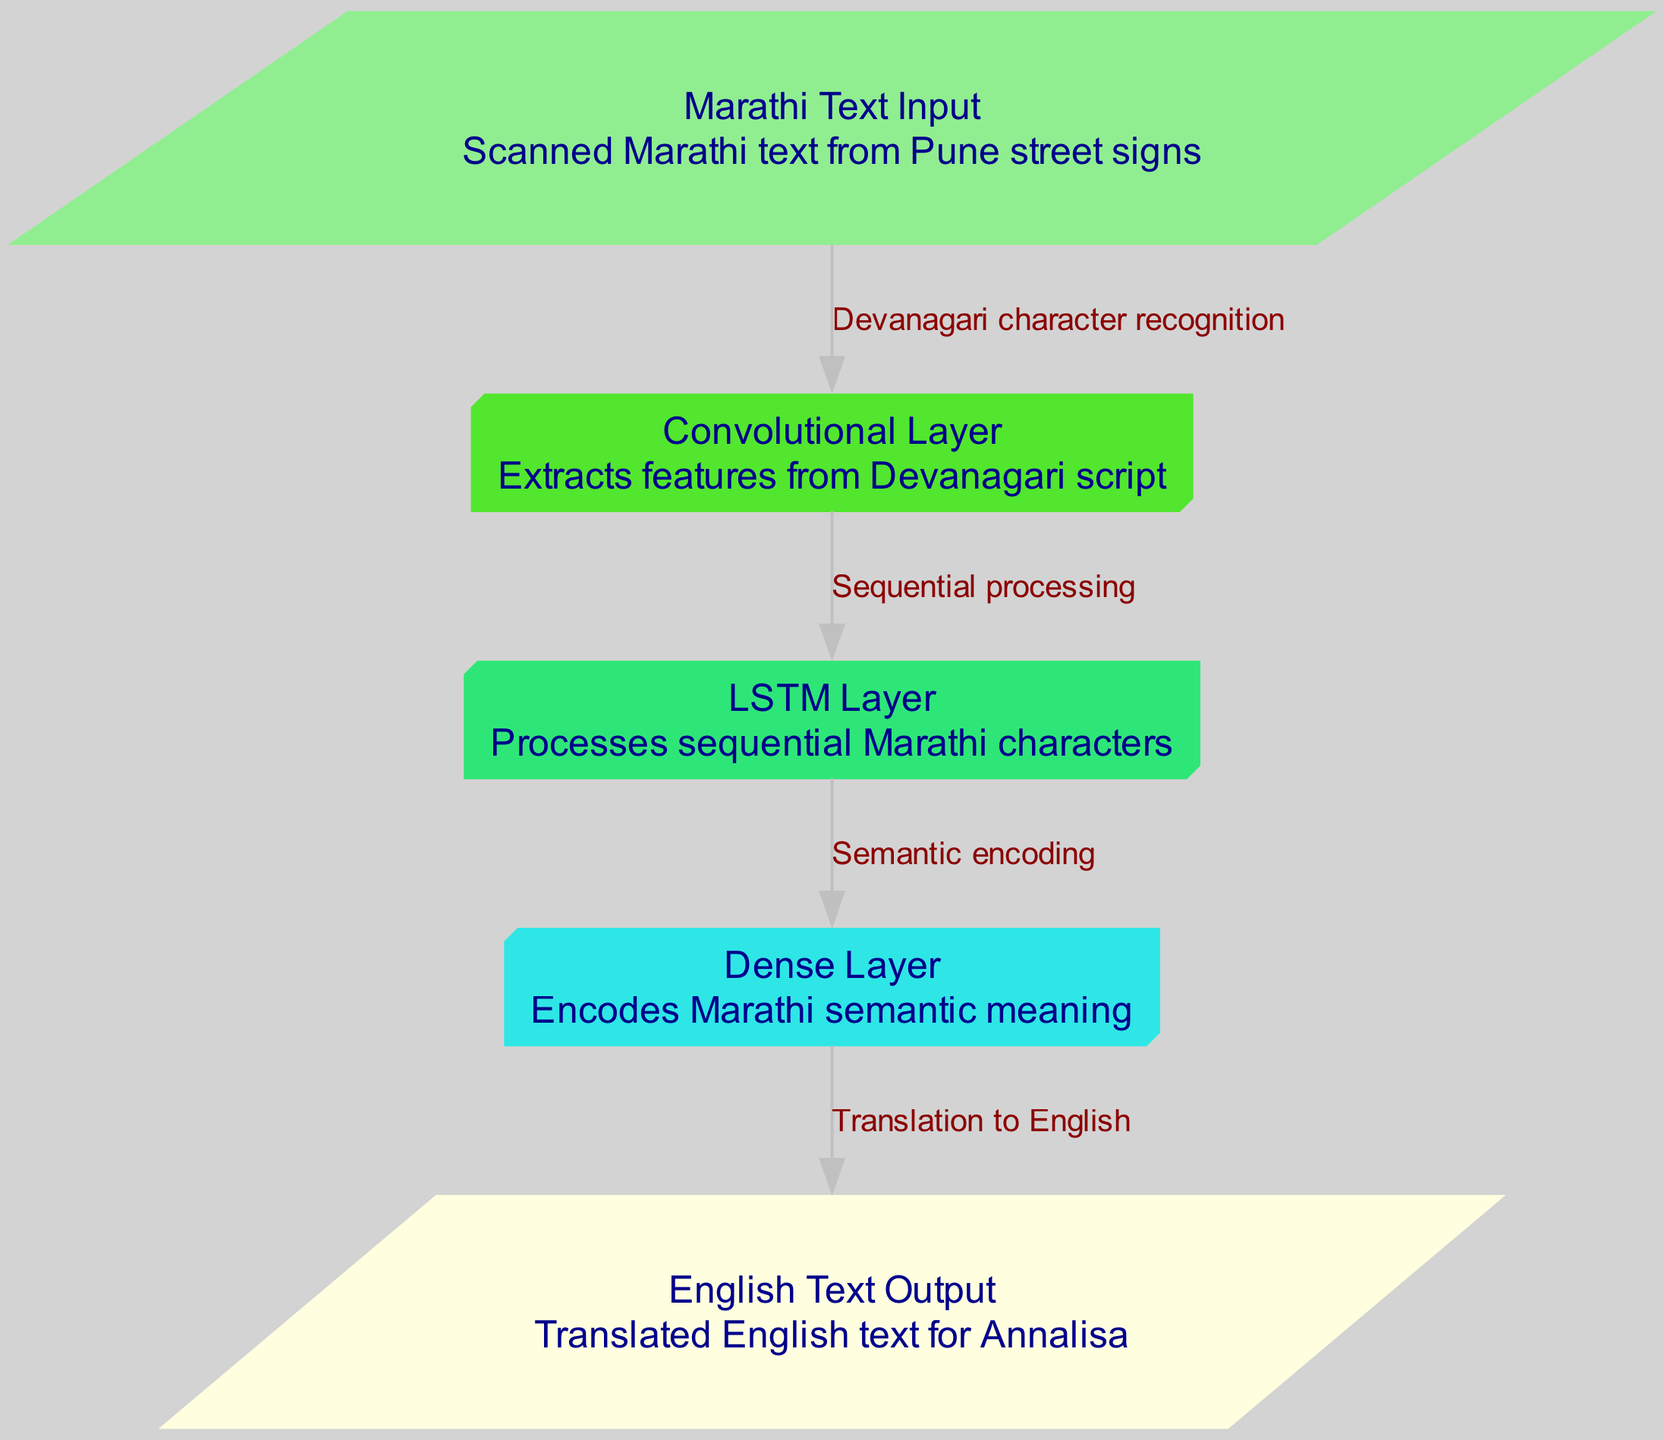What is the input layer of the diagram? The input layer is labeled "Marathi Text Input," and its description mentions "Scanned Marathi text from Pune street signs."
Answer: Marathi Text Input How many hidden layers are present in the neural network? The diagram indicates there are three hidden layers: a Convolutional Layer, an LSTM Layer, and a Dense Layer.
Answer: 3 What does the Convolutional Layer do? The Convolutional Layer is described as "Extracts features from Devanagari script," indicating its role in identifying patterns in the input text.
Answer: Extracts features from Devanagari script Which layer processes the sequential Marathi characters? The diagram specifies that the LSTM Layer processes sequential Marathi characters, as described in its function.
Answer: LSTM Layer What is the purpose of the Dense Layer in the diagram? The Dense Layer is described as "Encodes Marathi semantic meaning," which shows it is responsible for understanding the meanings of the text.
Answer: Encodes Marathi semantic meaning What is the output of this neural network? According to the output layer's label and description, the output is "English Text Output," which refers to the translated English text.
Answer: English Text Output Which connection indicates the sequential processing of data? The connection from the Convolutional Layer to the LSTM Layer is labeled "Sequential processing," clearly indicating the flow of sequential data processing.
Answer: Sequential processing Which layer's output is translated into English? The output of the Dense Layer is translated into English, as the connection to the English Text Output indicates.
Answer: Dense Layer How does the diagram describe the relationship between the input and the first hidden layer? The connection from the "Marathi Text Input" to the "Convolutional Layer" is labeled "Devanagari character recognition," defining how the input is processed by the first hidden layer.
Answer: Devanagari character recognition 